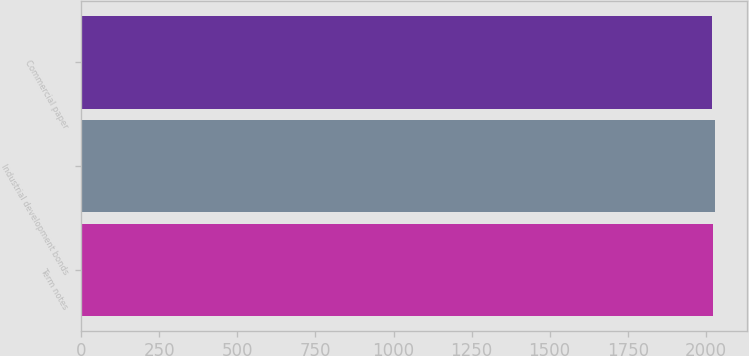Convert chart to OTSL. <chart><loc_0><loc_0><loc_500><loc_500><bar_chart><fcel>Term notes<fcel>Industrial development bonds<fcel>Commercial paper<nl><fcel>2024<fcel>2030<fcel>2019<nl></chart> 